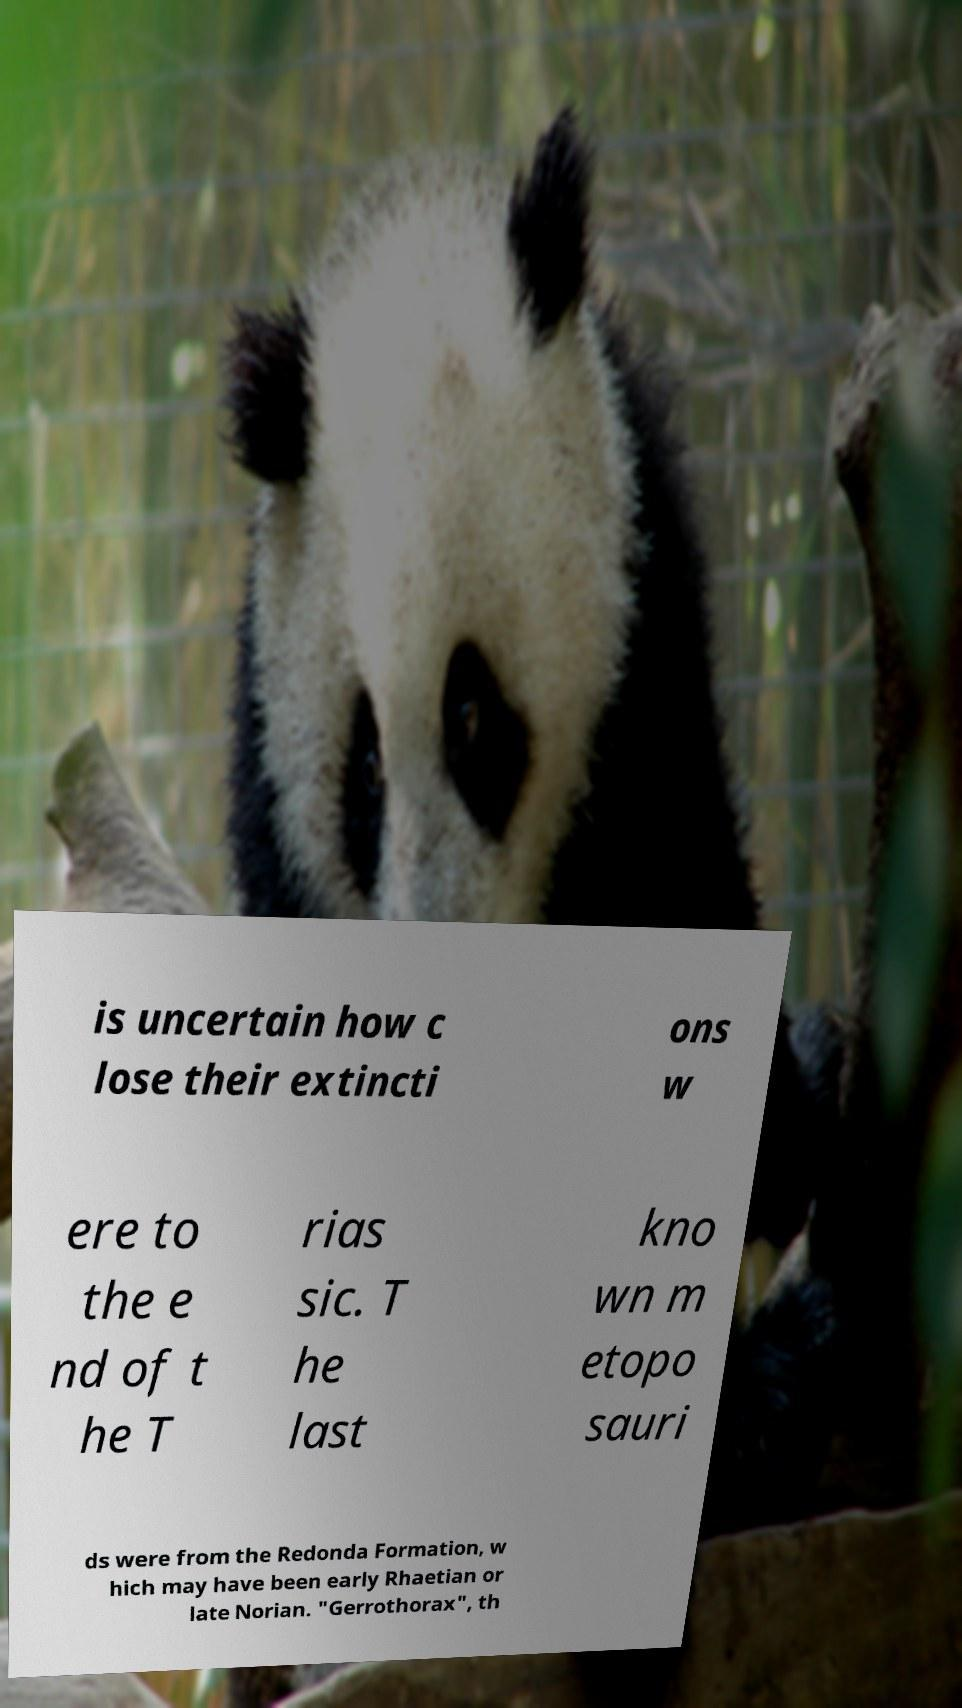Can you accurately transcribe the text from the provided image for me? is uncertain how c lose their extincti ons w ere to the e nd of t he T rias sic. T he last kno wn m etopo sauri ds were from the Redonda Formation, w hich may have been early Rhaetian or late Norian. "Gerrothorax", th 